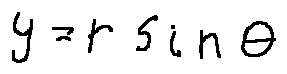<formula> <loc_0><loc_0><loc_500><loc_500>y = r \sin \theta</formula> 